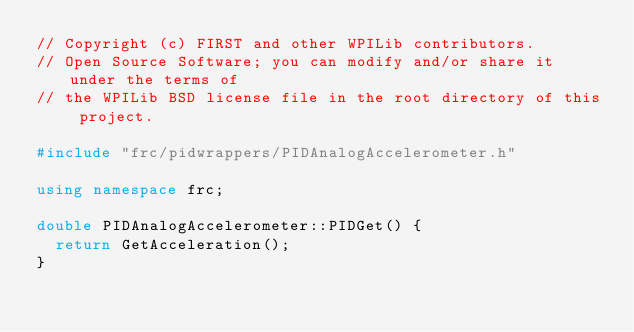Convert code to text. <code><loc_0><loc_0><loc_500><loc_500><_C++_>// Copyright (c) FIRST and other WPILib contributors.
// Open Source Software; you can modify and/or share it under the terms of
// the WPILib BSD license file in the root directory of this project.

#include "frc/pidwrappers/PIDAnalogAccelerometer.h"

using namespace frc;

double PIDAnalogAccelerometer::PIDGet() {
  return GetAcceleration();
}
</code> 